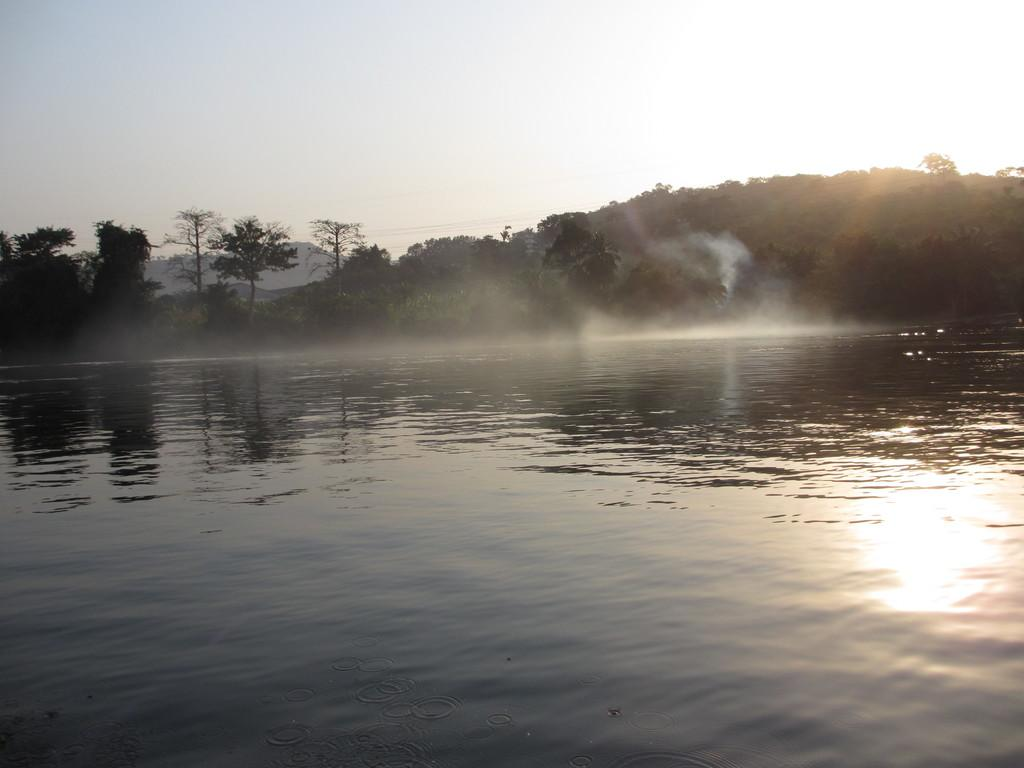What type of natural feature is present in the image? There is a sea in the image. What can be seen on the water surface? The sky is reflected on the water surface, and sunlight is visible on the water surface. What type of vegetation is present in the image? There are trees and plants in the image. What part of the sky is visible in the image? The sky is visible in the image. What type of jail can be seen in the image? There is no jail present in the image; it features a sea, trees, and plants. What type of apparel is worn by the trees in the image? Trees do not wear apparel; they are natural vegetation. 